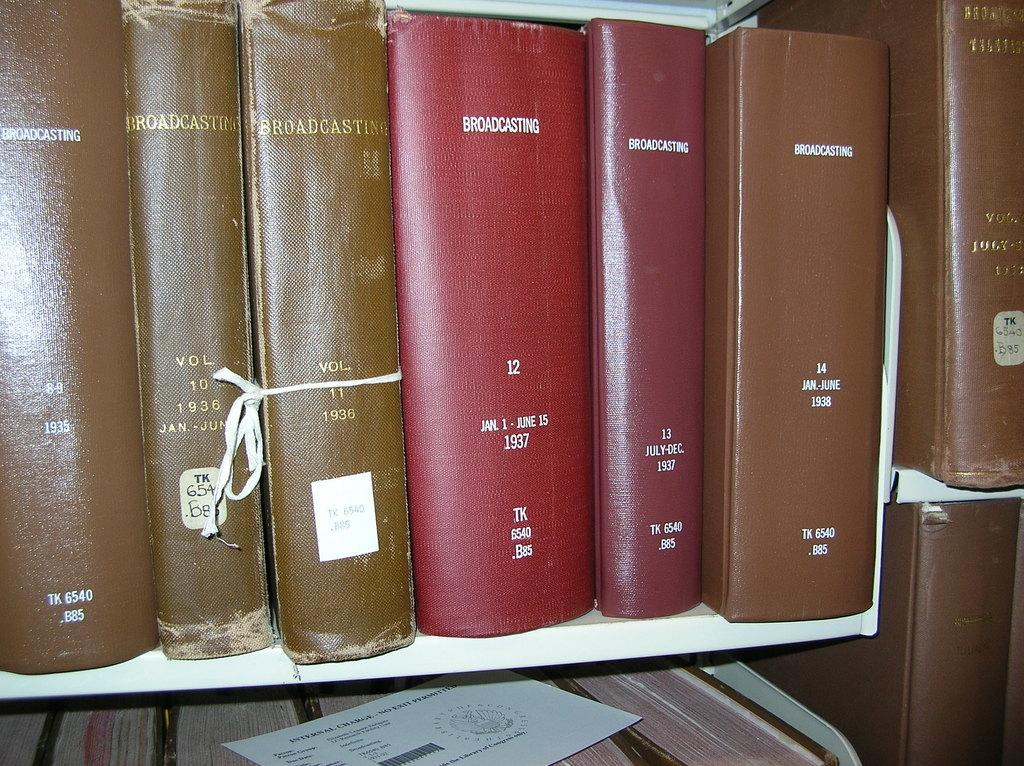<image>
Share a concise interpretation of the image provided. Some large books on a library shelf including one titled "Broadcasting" 